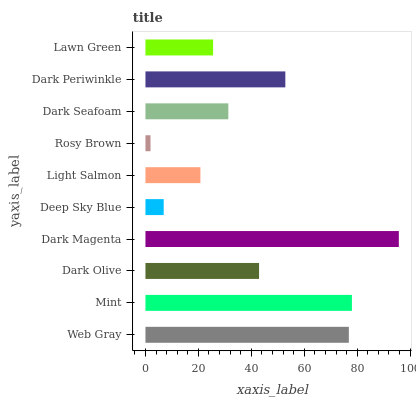Is Rosy Brown the minimum?
Answer yes or no. Yes. Is Dark Magenta the maximum?
Answer yes or no. Yes. Is Mint the minimum?
Answer yes or no. No. Is Mint the maximum?
Answer yes or no. No. Is Mint greater than Web Gray?
Answer yes or no. Yes. Is Web Gray less than Mint?
Answer yes or no. Yes. Is Web Gray greater than Mint?
Answer yes or no. No. Is Mint less than Web Gray?
Answer yes or no. No. Is Dark Olive the high median?
Answer yes or no. Yes. Is Dark Seafoam the low median?
Answer yes or no. Yes. Is Lawn Green the high median?
Answer yes or no. No. Is Web Gray the low median?
Answer yes or no. No. 